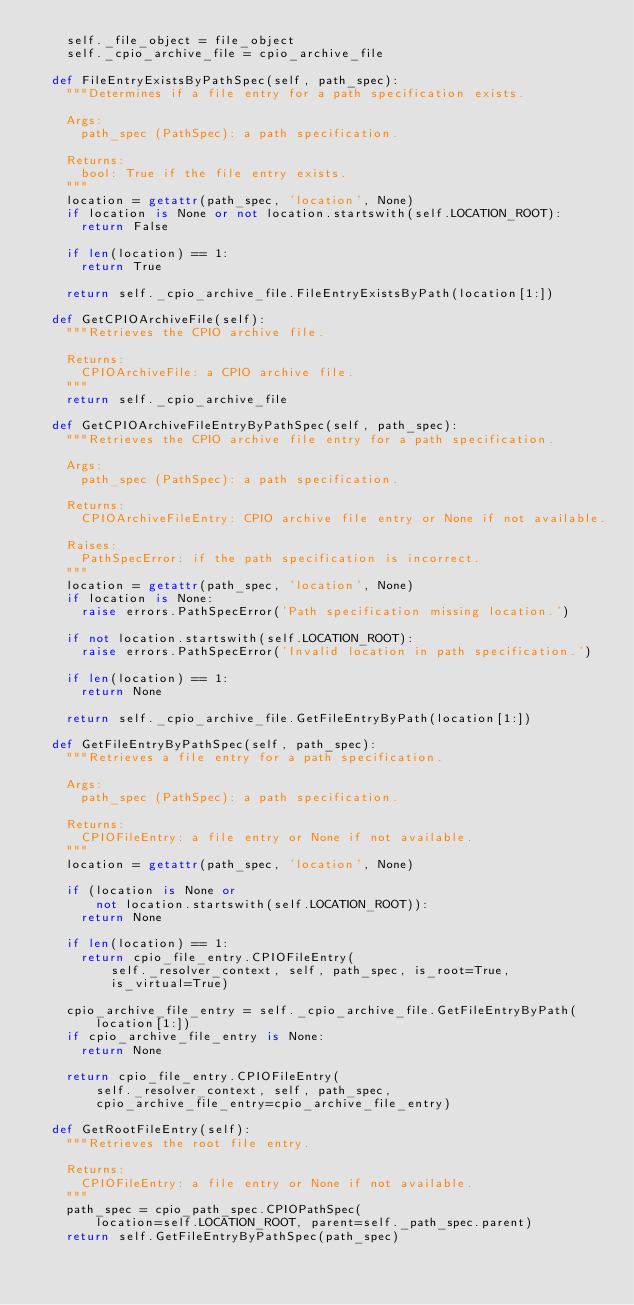<code> <loc_0><loc_0><loc_500><loc_500><_Python_>    self._file_object = file_object
    self._cpio_archive_file = cpio_archive_file

  def FileEntryExistsByPathSpec(self, path_spec):
    """Determines if a file entry for a path specification exists.

    Args:
      path_spec (PathSpec): a path specification.

    Returns:
      bool: True if the file entry exists.
    """
    location = getattr(path_spec, 'location', None)
    if location is None or not location.startswith(self.LOCATION_ROOT):
      return False

    if len(location) == 1:
      return True

    return self._cpio_archive_file.FileEntryExistsByPath(location[1:])

  def GetCPIOArchiveFile(self):
    """Retrieves the CPIO archive file.

    Returns:
      CPIOArchiveFile: a CPIO archive file.
    """
    return self._cpio_archive_file

  def GetCPIOArchiveFileEntryByPathSpec(self, path_spec):
    """Retrieves the CPIO archive file entry for a path specification.

    Args:
      path_spec (PathSpec): a path specification.

    Returns:
      CPIOArchiveFileEntry: CPIO archive file entry or None if not available.

    Raises:
      PathSpecError: if the path specification is incorrect.
    """
    location = getattr(path_spec, 'location', None)
    if location is None:
      raise errors.PathSpecError('Path specification missing location.')

    if not location.startswith(self.LOCATION_ROOT):
      raise errors.PathSpecError('Invalid location in path specification.')

    if len(location) == 1:
      return None

    return self._cpio_archive_file.GetFileEntryByPath(location[1:])

  def GetFileEntryByPathSpec(self, path_spec):
    """Retrieves a file entry for a path specification.

    Args:
      path_spec (PathSpec): a path specification.

    Returns:
      CPIOFileEntry: a file entry or None if not available.
    """
    location = getattr(path_spec, 'location', None)

    if (location is None or
        not location.startswith(self.LOCATION_ROOT)):
      return None

    if len(location) == 1:
      return cpio_file_entry.CPIOFileEntry(
          self._resolver_context, self, path_spec, is_root=True,
          is_virtual=True)

    cpio_archive_file_entry = self._cpio_archive_file.GetFileEntryByPath(
        location[1:])
    if cpio_archive_file_entry is None:
      return None

    return cpio_file_entry.CPIOFileEntry(
        self._resolver_context, self, path_spec,
        cpio_archive_file_entry=cpio_archive_file_entry)

  def GetRootFileEntry(self):
    """Retrieves the root file entry.

    Returns:
      CPIOFileEntry: a file entry or None if not available.
    """
    path_spec = cpio_path_spec.CPIOPathSpec(
        location=self.LOCATION_ROOT, parent=self._path_spec.parent)
    return self.GetFileEntryByPathSpec(path_spec)
</code> 